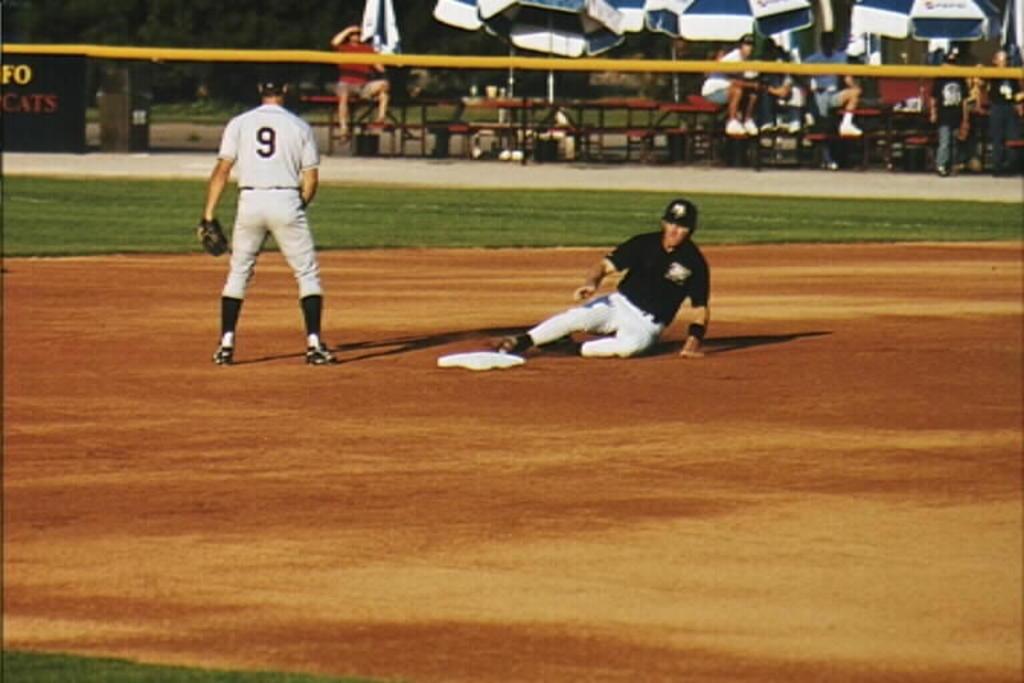What is the number of the fielder standing next to second base?
Keep it short and to the point. 9. 